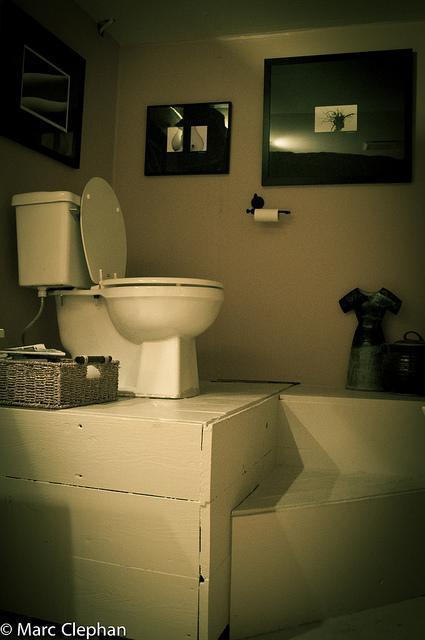How many humans in this picture?
Give a very brief answer. 0. How many people are wearing a white shirt?
Give a very brief answer. 0. 